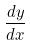Convert formula to latex. <formula><loc_0><loc_0><loc_500><loc_500>\frac { d y } { d x }</formula> 